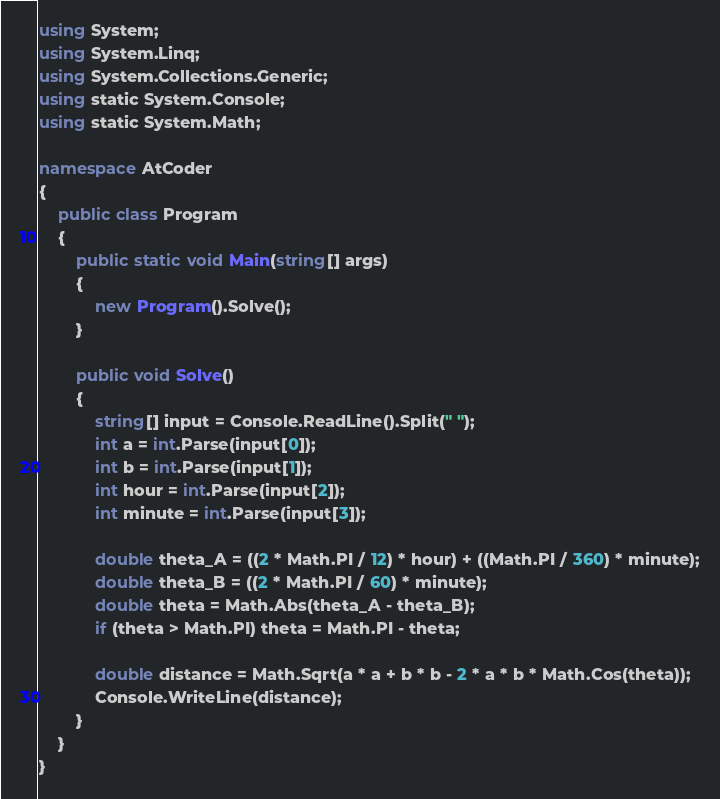<code> <loc_0><loc_0><loc_500><loc_500><_C#_>using System;
using System.Linq;
using System.Collections.Generic;
using static System.Console;
using static System.Math;

namespace AtCoder
{
    public class Program
    {
        public static void Main(string[] args)
        {
            new Program().Solve();
        }

        public void Solve()
        {
            string[] input = Console.ReadLine().Split(" ");
            int a = int.Parse(input[0]);
            int b = int.Parse(input[1]);
            int hour = int.Parse(input[2]);
            int minute = int.Parse(input[3]);

            double theta_A = ((2 * Math.PI / 12) * hour) + ((Math.PI / 360) * minute);
            double theta_B = ((2 * Math.PI / 60) * minute);
            double theta = Math.Abs(theta_A - theta_B);
            if (theta > Math.PI) theta = Math.PI - theta;

            double distance = Math.Sqrt(a * a + b * b - 2 * a * b * Math.Cos(theta));
            Console.WriteLine(distance);
        }
    }
}</code> 